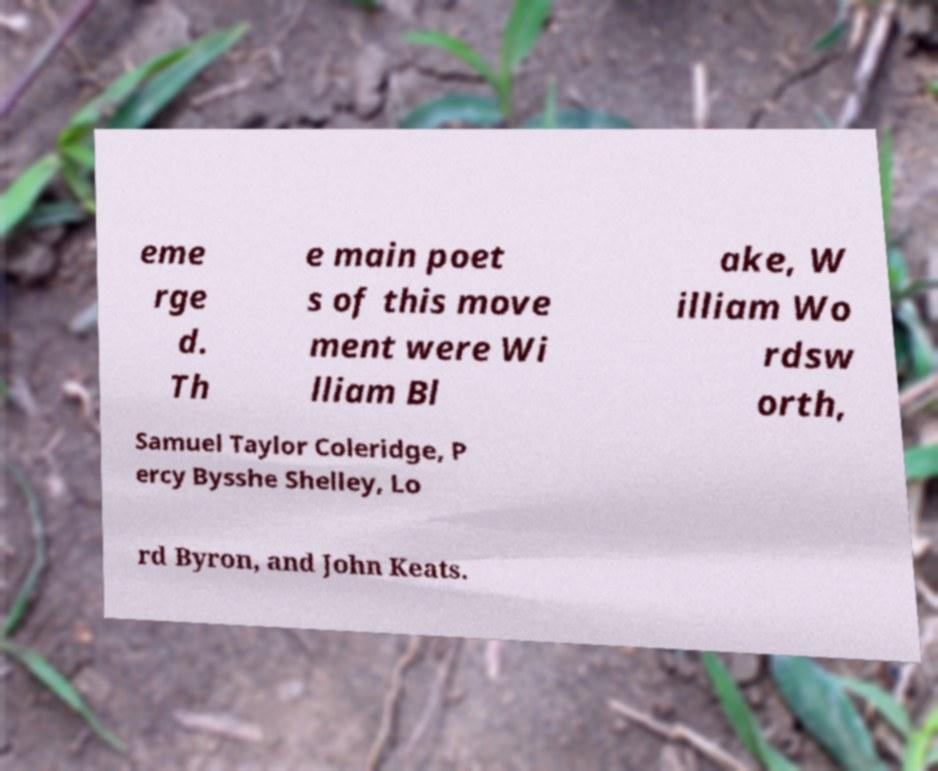There's text embedded in this image that I need extracted. Can you transcribe it verbatim? eme rge d. Th e main poet s of this move ment were Wi lliam Bl ake, W illiam Wo rdsw orth, Samuel Taylor Coleridge, P ercy Bysshe Shelley, Lo rd Byron, and John Keats. 